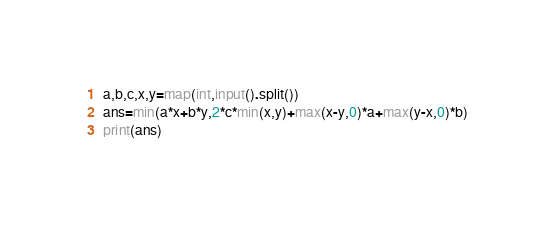<code> <loc_0><loc_0><loc_500><loc_500><_Python_>a,b,c,x,y=map(int,input().split())
ans=min(a*x+b*y,2*c*min(x,y)+max(x-y,0)*a+max(y-x,0)*b)
print(ans)</code> 